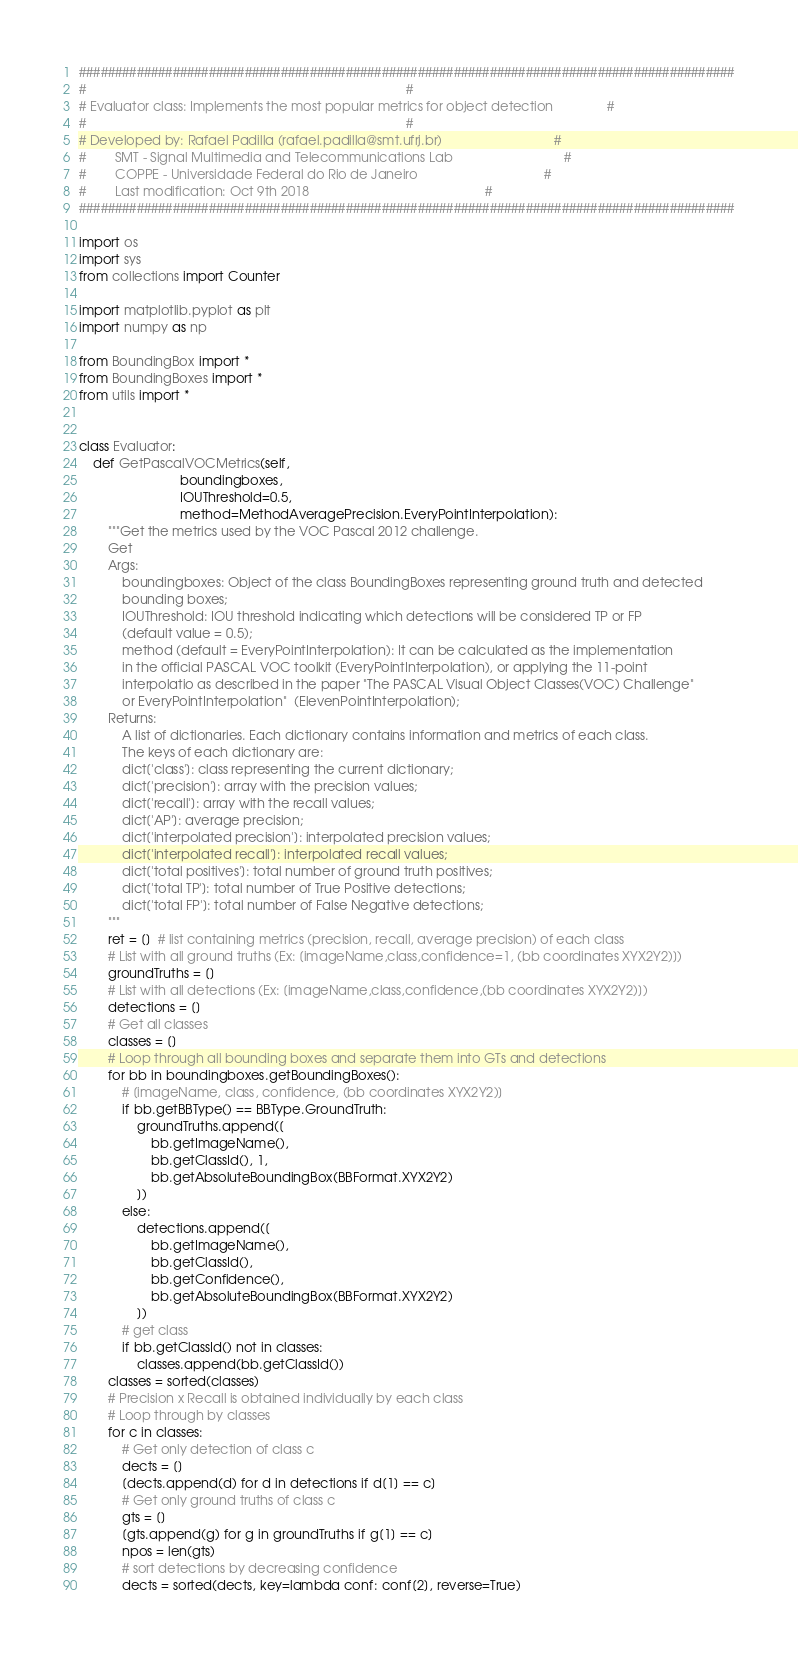<code> <loc_0><loc_0><loc_500><loc_500><_Python_>###########################################################################################
#                                                                                         #
# Evaluator class: Implements the most popular metrics for object detection               #
#                                                                                         #
# Developed by: Rafael Padilla (rafael.padilla@smt.ufrj.br)                               #
#        SMT - Signal Multimedia and Telecommunications Lab                               #
#        COPPE - Universidade Federal do Rio de Janeiro                                   #
#        Last modification: Oct 9th 2018                                                 #
###########################################################################################

import os
import sys
from collections import Counter

import matplotlib.pyplot as plt
import numpy as np

from BoundingBox import *
from BoundingBoxes import *
from utils import *


class Evaluator:
    def GetPascalVOCMetrics(self,
                            boundingboxes,
                            IOUThreshold=0.5,
                            method=MethodAveragePrecision.EveryPointInterpolation):
        """Get the metrics used by the VOC Pascal 2012 challenge.
        Get
        Args:
            boundingboxes: Object of the class BoundingBoxes representing ground truth and detected
            bounding boxes;
            IOUThreshold: IOU threshold indicating which detections will be considered TP or FP
            (default value = 0.5);
            method (default = EveryPointInterpolation): It can be calculated as the implementation
            in the official PASCAL VOC toolkit (EveryPointInterpolation), or applying the 11-point
            interpolatio as described in the paper "The PASCAL Visual Object Classes(VOC) Challenge"
            or EveryPointInterpolation"  (ElevenPointInterpolation);
        Returns:
            A list of dictionaries. Each dictionary contains information and metrics of each class.
            The keys of each dictionary are:
            dict['class']: class representing the current dictionary;
            dict['precision']: array with the precision values;
            dict['recall']: array with the recall values;
            dict['AP']: average precision;
            dict['interpolated precision']: interpolated precision values;
            dict['interpolated recall']: interpolated recall values;
            dict['total positives']: total number of ground truth positives;
            dict['total TP']: total number of True Positive detections;
            dict['total FP']: total number of False Negative detections;
        """
        ret = []  # list containing metrics (precision, recall, average precision) of each class
        # List with all ground truths (Ex: [imageName,class,confidence=1, (bb coordinates XYX2Y2)])
        groundTruths = []
        # List with all detections (Ex: [imageName,class,confidence,(bb coordinates XYX2Y2)])
        detections = []
        # Get all classes
        classes = []
        # Loop through all bounding boxes and separate them into GTs and detections
        for bb in boundingboxes.getBoundingBoxes():
            # [imageName, class, confidence, (bb coordinates XYX2Y2)]
            if bb.getBBType() == BBType.GroundTruth:
                groundTruths.append([
                    bb.getImageName(),
                    bb.getClassId(), 1,
                    bb.getAbsoluteBoundingBox(BBFormat.XYX2Y2)
                ])
            else:
                detections.append([
                    bb.getImageName(),
                    bb.getClassId(),
                    bb.getConfidence(),
                    bb.getAbsoluteBoundingBox(BBFormat.XYX2Y2)
                ])
            # get class
            if bb.getClassId() not in classes:
                classes.append(bb.getClassId())
        classes = sorted(classes)
        # Precision x Recall is obtained individually by each class
        # Loop through by classes
        for c in classes:
            # Get only detection of class c
            dects = []
            [dects.append(d) for d in detections if d[1] == c]
            # Get only ground truths of class c
            gts = []
            [gts.append(g) for g in groundTruths if g[1] == c]
            npos = len(gts)
            # sort detections by decreasing confidence
            dects = sorted(dects, key=lambda conf: conf[2], reverse=True)</code> 